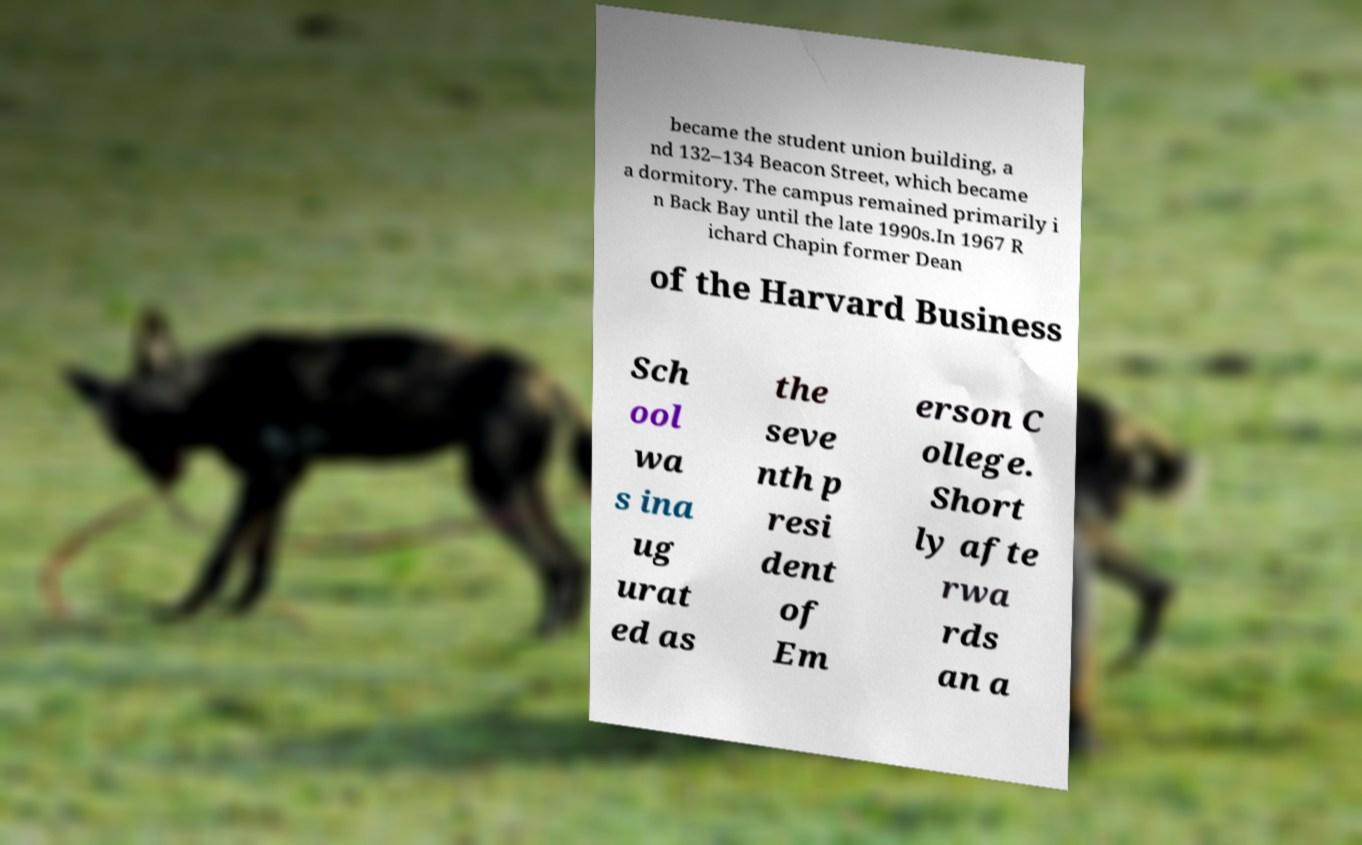I need the written content from this picture converted into text. Can you do that? became the student union building, a nd 132–134 Beacon Street, which became a dormitory. The campus remained primarily i n Back Bay until the late 1990s.In 1967 R ichard Chapin former Dean of the Harvard Business Sch ool wa s ina ug urat ed as the seve nth p resi dent of Em erson C ollege. Short ly afte rwa rds an a 